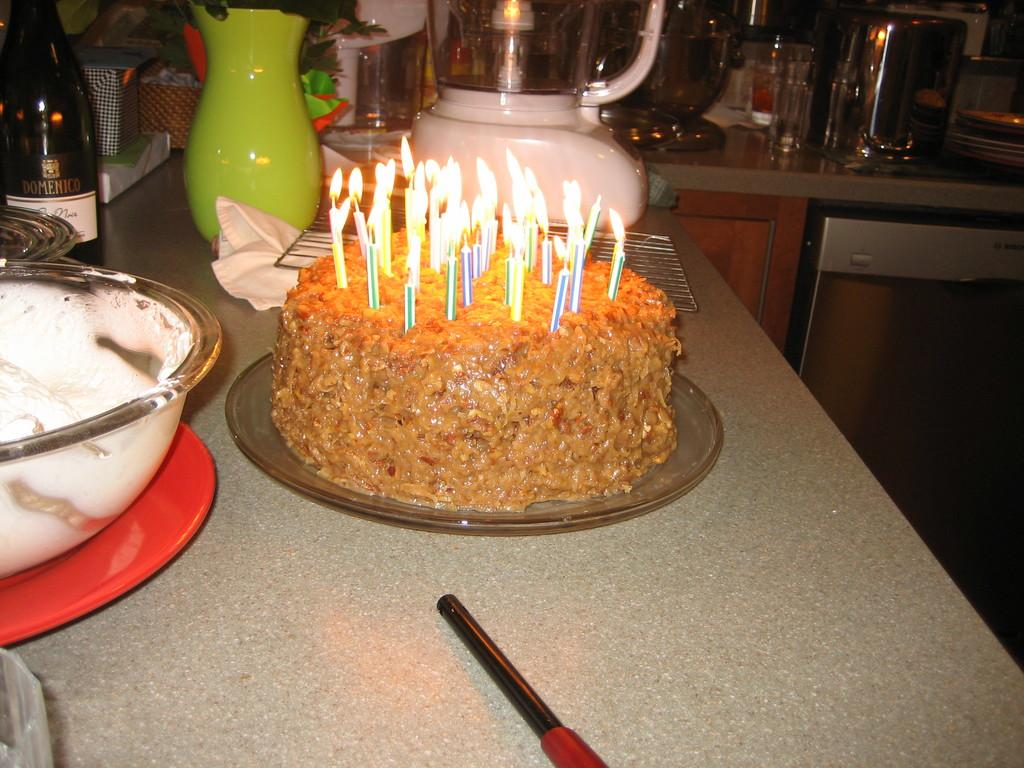What is the main object on the glass plate in the image? There is a cake on a glass plate in the image. What is used to provide light in the image? There are candles in the image. What type of containers are present in the image? There are bowls in the image. What type of liquid-holding containers are present in the image? There are bottles in the image. What is the color of the surface on which objects are placed in the image? There are objects on a brown color surface in the image. What type of truck can be seen driving through the cake in the image? There is no truck present in the image, and the cake is not being driven through by any vehicle. 